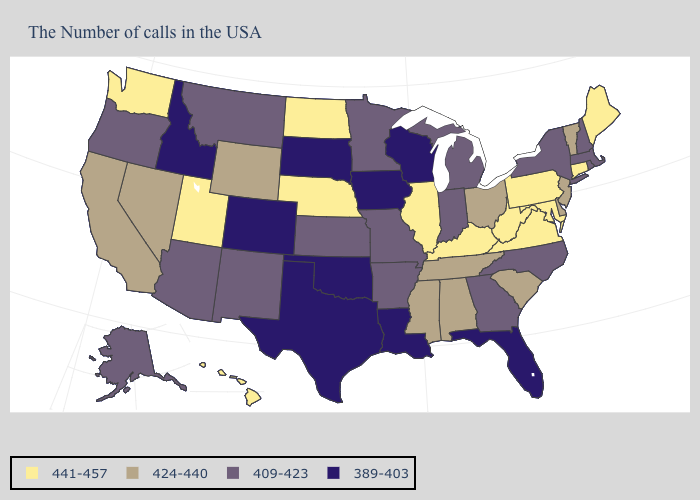Name the states that have a value in the range 409-423?
Concise answer only. Massachusetts, Rhode Island, New Hampshire, New York, North Carolina, Georgia, Michigan, Indiana, Missouri, Arkansas, Minnesota, Kansas, New Mexico, Montana, Arizona, Oregon, Alaska. Name the states that have a value in the range 389-403?
Concise answer only. Florida, Wisconsin, Louisiana, Iowa, Oklahoma, Texas, South Dakota, Colorado, Idaho. What is the value of Indiana?
Quick response, please. 409-423. What is the value of Michigan?
Concise answer only. 409-423. Name the states that have a value in the range 409-423?
Quick response, please. Massachusetts, Rhode Island, New Hampshire, New York, North Carolina, Georgia, Michigan, Indiana, Missouri, Arkansas, Minnesota, Kansas, New Mexico, Montana, Arizona, Oregon, Alaska. Among the states that border Ohio , does Indiana have the lowest value?
Answer briefly. Yes. Name the states that have a value in the range 389-403?
Keep it brief. Florida, Wisconsin, Louisiana, Iowa, Oklahoma, Texas, South Dakota, Colorado, Idaho. Among the states that border Wyoming , does South Dakota have the highest value?
Quick response, please. No. Name the states that have a value in the range 424-440?
Be succinct. Vermont, New Jersey, Delaware, South Carolina, Ohio, Alabama, Tennessee, Mississippi, Wyoming, Nevada, California. Name the states that have a value in the range 409-423?
Give a very brief answer. Massachusetts, Rhode Island, New Hampshire, New York, North Carolina, Georgia, Michigan, Indiana, Missouri, Arkansas, Minnesota, Kansas, New Mexico, Montana, Arizona, Oregon, Alaska. What is the lowest value in the USA?
Write a very short answer. 389-403. What is the highest value in states that border Alabama?
Keep it brief. 424-440. Does California have the highest value in the West?
Give a very brief answer. No. Name the states that have a value in the range 389-403?
Short answer required. Florida, Wisconsin, Louisiana, Iowa, Oklahoma, Texas, South Dakota, Colorado, Idaho. What is the lowest value in the West?
Concise answer only. 389-403. 